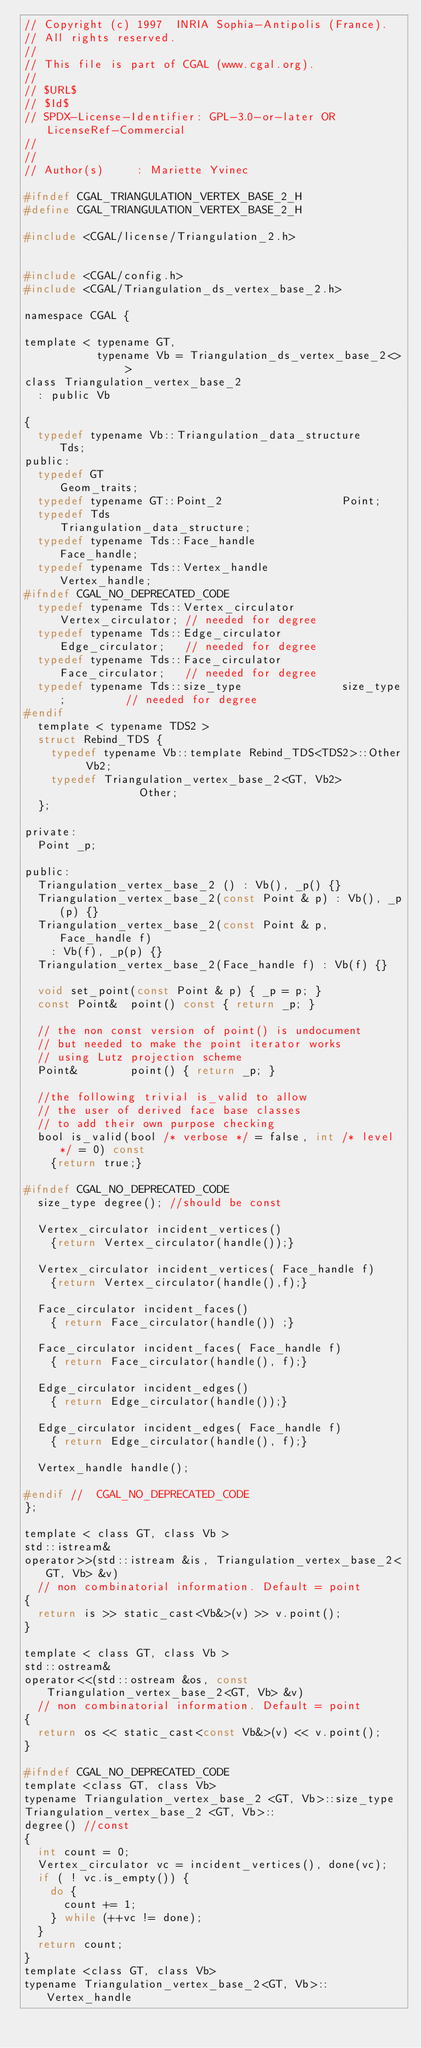Convert code to text. <code><loc_0><loc_0><loc_500><loc_500><_C_>// Copyright (c) 1997  INRIA Sophia-Antipolis (France).
// All rights reserved.
//
// This file is part of CGAL (www.cgal.org).
//
// $URL$
// $Id$
// SPDX-License-Identifier: GPL-3.0-or-later OR LicenseRef-Commercial
//
//
// Author(s)     : Mariette Yvinec

#ifndef CGAL_TRIANGULATION_VERTEX_BASE_2_H
#define CGAL_TRIANGULATION_VERTEX_BASE_2_H

#include <CGAL/license/Triangulation_2.h>


#include <CGAL/config.h>
#include <CGAL/Triangulation_ds_vertex_base_2.h>

namespace CGAL {

template < typename GT,
           typename Vb = Triangulation_ds_vertex_base_2<> >
class Triangulation_vertex_base_2
  : public Vb

{
  typedef typename Vb::Triangulation_data_structure    Tds;
public:
  typedef GT                                    Geom_traits;
  typedef typename GT::Point_2                  Point;
  typedef Tds                                   Triangulation_data_structure;
  typedef typename Tds::Face_handle             Face_handle;
  typedef typename Tds::Vertex_handle           Vertex_handle;
#ifndef CGAL_NO_DEPRECATED_CODE
  typedef typename Tds::Vertex_circulator       Vertex_circulator; // needed for degree
  typedef typename Tds::Edge_circulator         Edge_circulator;   // needed for degree
  typedef typename Tds::Face_circulator         Face_circulator;   // needed for degree
  typedef typename Tds::size_type               size_type;         // needed for degree
#endif
  template < typename TDS2 >
  struct Rebind_TDS {
    typedef typename Vb::template Rebind_TDS<TDS2>::Other  Vb2;
    typedef Triangulation_vertex_base_2<GT, Vb2>           Other;
  };

private:
  Point _p;

public:
  Triangulation_vertex_base_2 () : Vb(), _p() {}
  Triangulation_vertex_base_2(const Point & p) : Vb(), _p(p) {}
  Triangulation_vertex_base_2(const Point & p, Face_handle f)
    : Vb(f), _p(p) {}
  Triangulation_vertex_base_2(Face_handle f) : Vb(f) {}

  void set_point(const Point & p) { _p = p; }
  const Point&  point() const { return _p; }

  // the non const version of point() is undocument
  // but needed to make the point iterator works
  // using Lutz projection scheme
  Point&        point() { return _p; }

  //the following trivial is_valid to allow
  // the user of derived face base classes
  // to add their own purpose checking
  bool is_valid(bool /* verbose */ = false, int /* level */ = 0) const
    {return true;}

#ifndef CGAL_NO_DEPRECATED_CODE
  size_type degree(); //should be const

  Vertex_circulator incident_vertices()
    {return Vertex_circulator(handle());}

  Vertex_circulator incident_vertices( Face_handle f)
    {return Vertex_circulator(handle(),f);}

  Face_circulator incident_faces()
    { return Face_circulator(handle()) ;}

  Face_circulator incident_faces( Face_handle f)
    { return Face_circulator(handle(), f);}

  Edge_circulator incident_edges()
    { return Edge_circulator(handle());}

  Edge_circulator incident_edges( Face_handle f)
    { return Edge_circulator(handle(), f);}

  Vertex_handle handle();

#endif //  CGAL_NO_DEPRECATED_CODE
};

template < class GT, class Vb >
std::istream&
operator>>(std::istream &is, Triangulation_vertex_base_2<GT, Vb> &v)
  // non combinatorial information. Default = point
{
  return is >> static_cast<Vb&>(v) >> v.point();
}

template < class GT, class Vb >
std::ostream&
operator<<(std::ostream &os, const Triangulation_vertex_base_2<GT, Vb> &v)
  // non combinatorial information. Default = point
{
  return os << static_cast<const Vb&>(v) << v.point();
}

#ifndef CGAL_NO_DEPRECATED_CODE
template <class GT, class Vb>
typename Triangulation_vertex_base_2 <GT, Vb>::size_type
Triangulation_vertex_base_2 <GT, Vb>::
degree() //const
{
  int count = 0;
  Vertex_circulator vc = incident_vertices(), done(vc);
  if ( ! vc.is_empty()) {
    do {
      count += 1;
    } while (++vc != done);
  }
  return count;
}
template <class GT, class Vb>
typename Triangulation_vertex_base_2<GT, Vb>::Vertex_handle</code> 